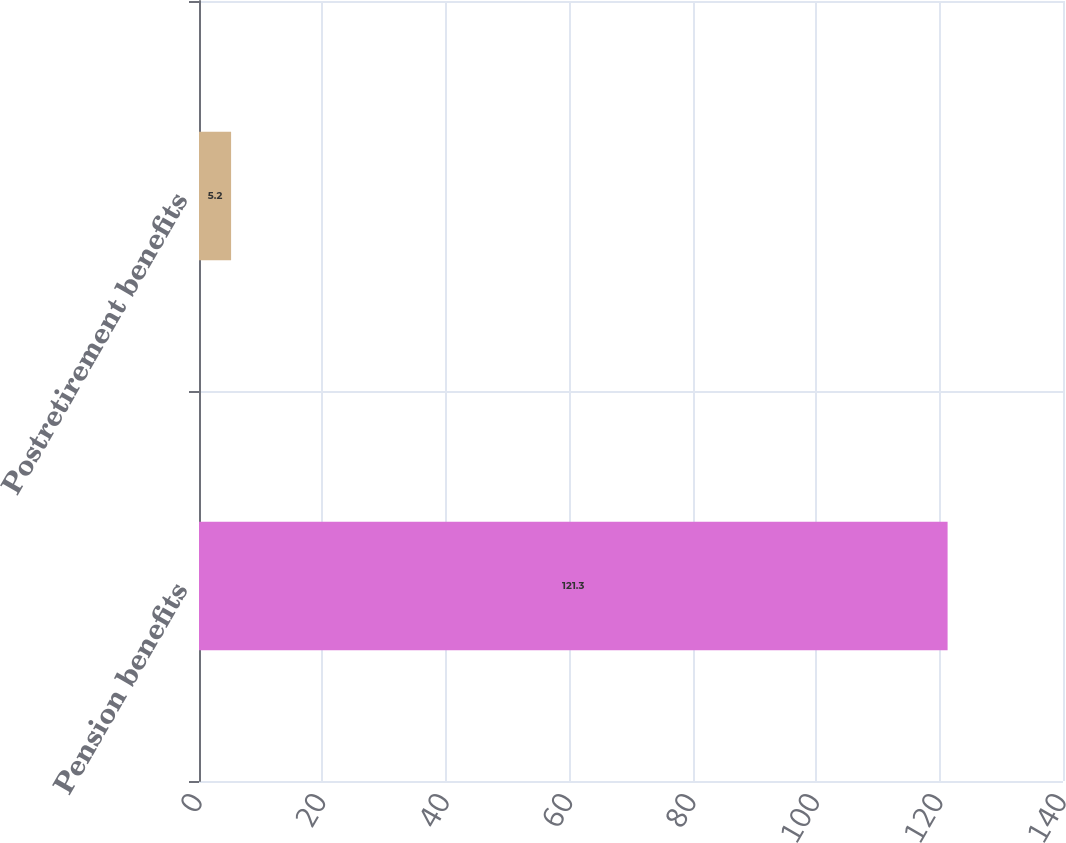Convert chart to OTSL. <chart><loc_0><loc_0><loc_500><loc_500><bar_chart><fcel>Pension benefits<fcel>Postretirement benefits<nl><fcel>121.3<fcel>5.2<nl></chart> 